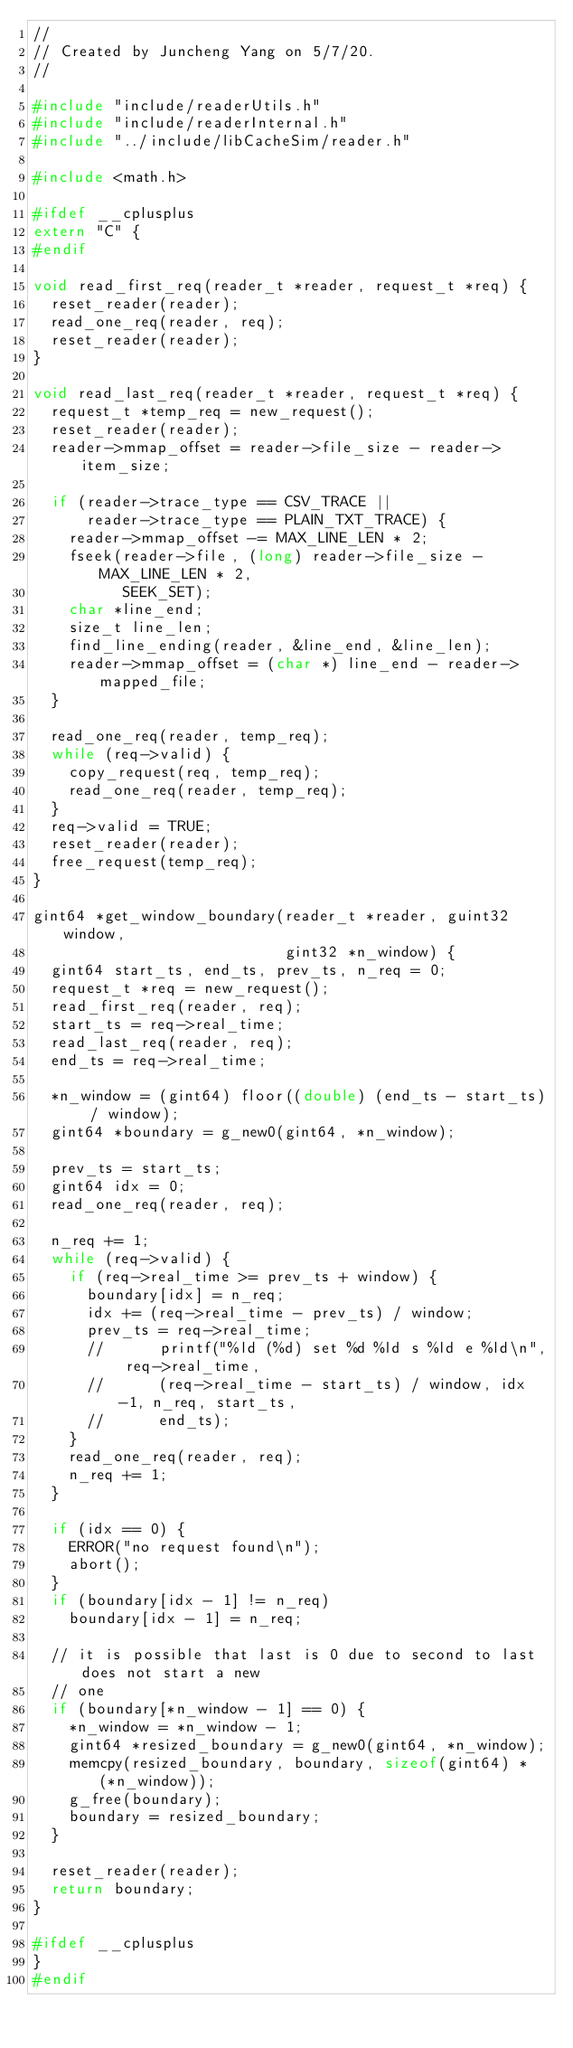Convert code to text. <code><loc_0><loc_0><loc_500><loc_500><_C_>//
// Created by Juncheng Yang on 5/7/20.
//

#include "include/readerUtils.h"
#include "include/readerInternal.h"
#include "../include/libCacheSim/reader.h"

#include <math.h>

#ifdef __cplusplus
extern "C" {
#endif

void read_first_req(reader_t *reader, request_t *req) {
  reset_reader(reader);
  read_one_req(reader, req);
  reset_reader(reader);
}

void read_last_req(reader_t *reader, request_t *req) {
  request_t *temp_req = new_request();
  reset_reader(reader);
  reader->mmap_offset = reader->file_size - reader->item_size;

  if (reader->trace_type == CSV_TRACE ||
      reader->trace_type == PLAIN_TXT_TRACE) {
    reader->mmap_offset -= MAX_LINE_LEN * 2;
    fseek(reader->file, (long) reader->file_size - MAX_LINE_LEN * 2,
          SEEK_SET);
    char *line_end;
    size_t line_len;
    find_line_ending(reader, &line_end, &line_len);
    reader->mmap_offset = (char *) line_end - reader->mapped_file;
  }

  read_one_req(reader, temp_req);
  while (req->valid) {
    copy_request(req, temp_req);
    read_one_req(reader, temp_req);
  }
  req->valid = TRUE;
  reset_reader(reader);
  free_request(temp_req);
}

gint64 *get_window_boundary(reader_t *reader, guint32 window,
                            gint32 *n_window) {
  gint64 start_ts, end_ts, prev_ts, n_req = 0;
  request_t *req = new_request();
  read_first_req(reader, req);
  start_ts = req->real_time;
  read_last_req(reader, req);
  end_ts = req->real_time;

  *n_window = (gint64) floor((double) (end_ts - start_ts) / window);
  gint64 *boundary = g_new0(gint64, *n_window);

  prev_ts = start_ts;
  gint64 idx = 0;
  read_one_req(reader, req);

  n_req += 1;
  while (req->valid) {
    if (req->real_time >= prev_ts + window) {
      boundary[idx] = n_req;
      idx += (req->real_time - prev_ts) / window;
      prev_ts = req->real_time;
      //      printf("%ld (%d) set %d %ld s %ld e %ld\n", req->real_time,
      //      (req->real_time - start_ts) / window, idx-1, n_req, start_ts,
      //      end_ts);
    }
    read_one_req(reader, req);
    n_req += 1;
  }

  if (idx == 0) {
    ERROR("no request found\n");
    abort();
  }
  if (boundary[idx - 1] != n_req)
    boundary[idx - 1] = n_req;

  // it is possible that last is 0 due to second to last does not start a new
  // one
  if (boundary[*n_window - 1] == 0) {
    *n_window = *n_window - 1;
    gint64 *resized_boundary = g_new0(gint64, *n_window);
    memcpy(resized_boundary, boundary, sizeof(gint64) * (*n_window));
    g_free(boundary);
    boundary = resized_boundary;
  }

  reset_reader(reader);
  return boundary;
}

#ifdef __cplusplus
}
#endif
</code> 